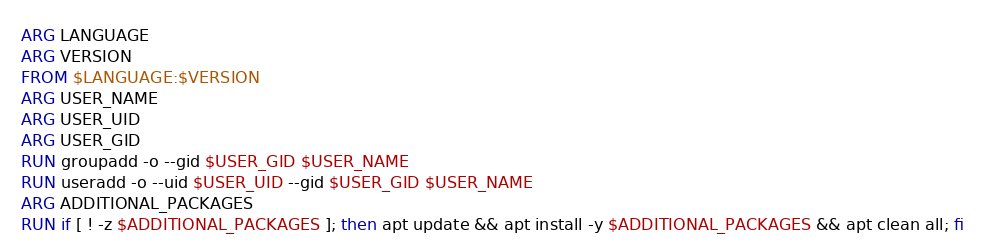Convert code to text. <code><loc_0><loc_0><loc_500><loc_500><_Dockerfile_>ARG LANGUAGE
ARG VERSION
FROM $LANGUAGE:$VERSION
ARG USER_NAME
ARG USER_UID
ARG USER_GID
RUN groupadd -o --gid $USER_GID $USER_NAME
RUN useradd -o --uid $USER_UID --gid $USER_GID $USER_NAME
ARG ADDITIONAL_PACKAGES
RUN if [ ! -z $ADDITIONAL_PACKAGES ]; then apt update && apt install -y $ADDITIONAL_PACKAGES && apt clean all; fi</code> 